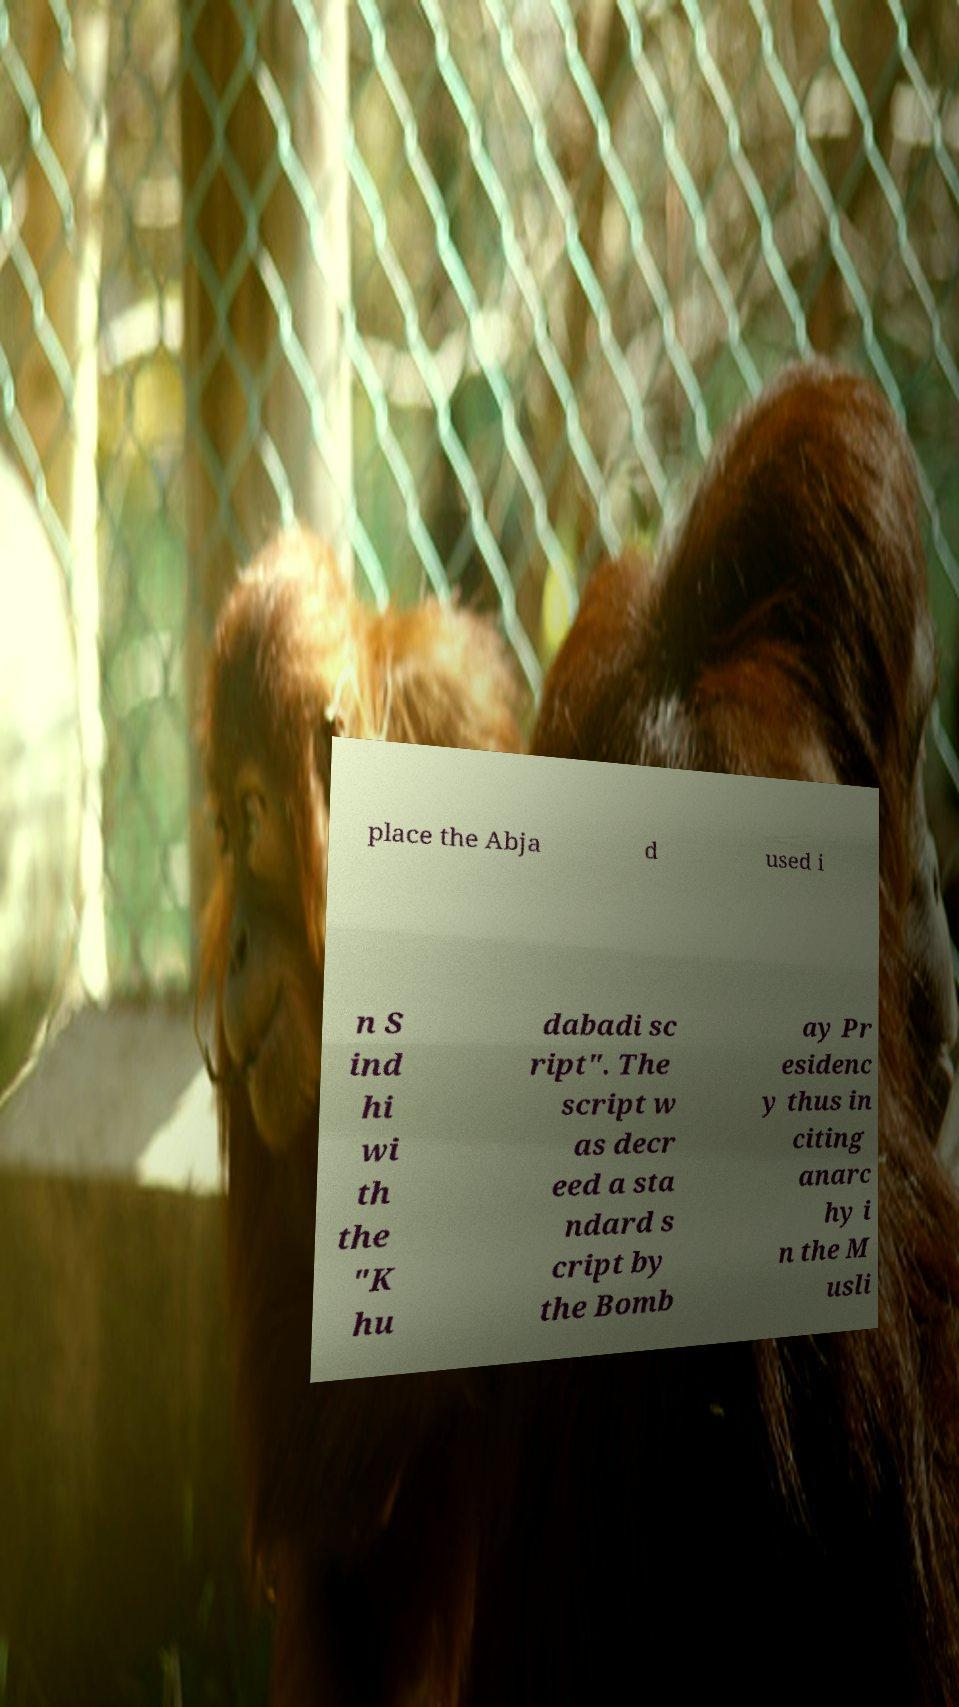Can you accurately transcribe the text from the provided image for me? place the Abja d used i n S ind hi wi th the "K hu dabadi sc ript". The script w as decr eed a sta ndard s cript by the Bomb ay Pr esidenc y thus in citing anarc hy i n the M usli 